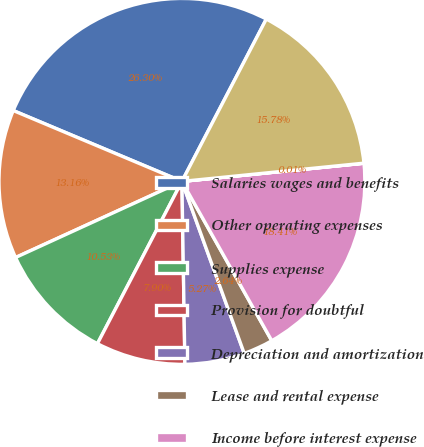<chart> <loc_0><loc_0><loc_500><loc_500><pie_chart><fcel>Salaries wages and benefits<fcel>Other operating expenses<fcel>Supplies expense<fcel>Provision for doubtful<fcel>Depreciation and amortization<fcel>Lease and rental expense<fcel>Income before interest expense<fcel>Interest expense net<fcel>Income before income taxes<nl><fcel>26.3%<fcel>13.16%<fcel>10.53%<fcel>7.9%<fcel>5.27%<fcel>2.64%<fcel>18.41%<fcel>0.01%<fcel>15.78%<nl></chart> 